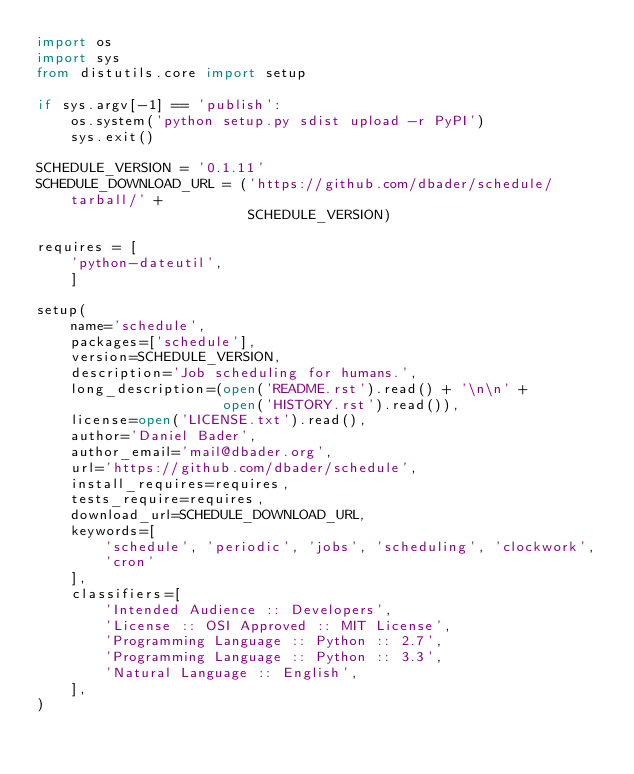<code> <loc_0><loc_0><loc_500><loc_500><_Python_>import os
import sys
from distutils.core import setup

if sys.argv[-1] == 'publish':
    os.system('python setup.py sdist upload -r PyPI')
    sys.exit()

SCHEDULE_VERSION = '0.1.11'
SCHEDULE_DOWNLOAD_URL = ('https://github.com/dbader/schedule/tarball/' +
                         SCHEDULE_VERSION)

requires = [
    'python-dateutil',
    ]

setup(
    name='schedule',
    packages=['schedule'],
    version=SCHEDULE_VERSION,
    description='Job scheduling for humans.',
    long_description=(open('README.rst').read() + '\n\n' +
                      open('HISTORY.rst').read()),
    license=open('LICENSE.txt').read(),
    author='Daniel Bader',
    author_email='mail@dbader.org',
    url='https://github.com/dbader/schedule',
    install_requires=requires,
    tests_require=requires,
    download_url=SCHEDULE_DOWNLOAD_URL,
    keywords=[
        'schedule', 'periodic', 'jobs', 'scheduling', 'clockwork',
        'cron'
    ],
    classifiers=[
        'Intended Audience :: Developers',
        'License :: OSI Approved :: MIT License',
        'Programming Language :: Python :: 2.7',
        'Programming Language :: Python :: 3.3',
        'Natural Language :: English',
    ],
)
</code> 